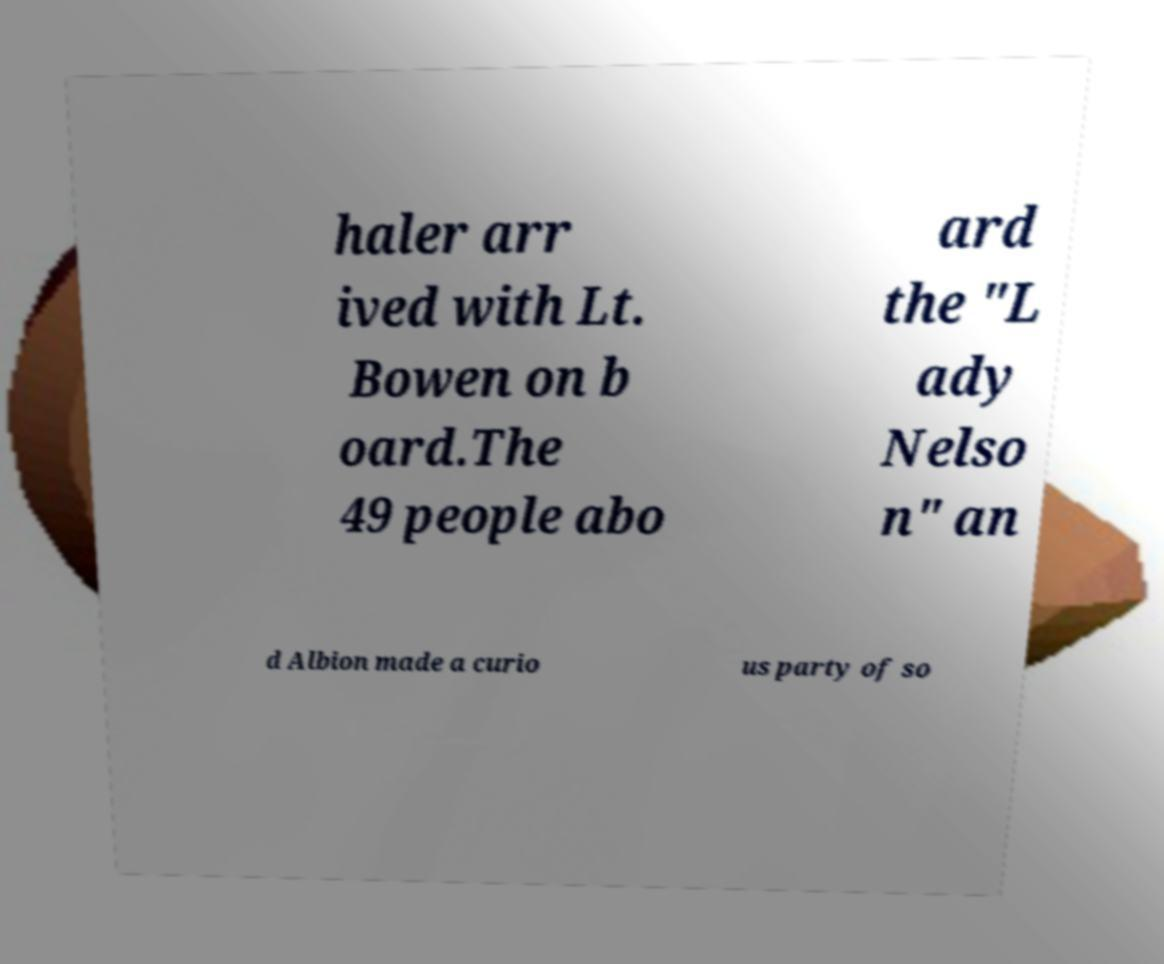What messages or text are displayed in this image? I need them in a readable, typed format. haler arr ived with Lt. Bowen on b oard.The 49 people abo ard the "L ady Nelso n" an d Albion made a curio us party of so 